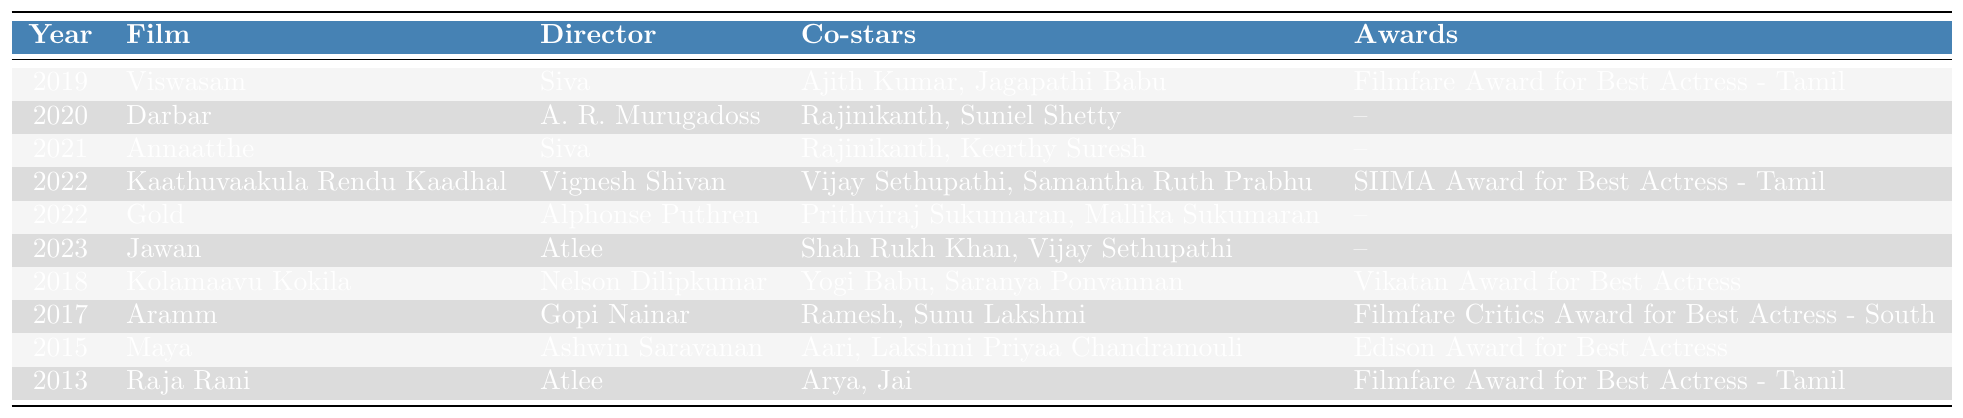What film did Nayanthara star in alongside Rajinikanth in 2020? The table shows that in the year 2020, Nayanthara starred in the film "Darbar," with Rajinikanth as a co-star.
Answer: Darbar How many awards did Nayanthara win for her film "Kaathuvaakula Rendu Kaadhal"? Referring to the row for "Kaathuvaakula Rendu Kaadhal" in 2022, the table indicates that she won one award: the SIIMA Award for Best Actress - Tamil.
Answer: One award Who directed the film "Kolamaavu Kokila"? The table lists "Kolamaavu Kokila" under the year 2018 and shows that it was directed by Nelson Dilipkumar.
Answer: Nelson Dilipkumar In which year did Nayanthara collaborate with director Siva, and what films did she feature in? Nayanthara worked with director Siva in two films, "Viswasam" in 2019 and "Annaatthe" in 2021.
Answer: 2019 and 2021 Did Nayanthara receive any awards for her performance in "Jawan"? The table shows that for the film "Jawan" in 2023, Nayanthara did not win any awards, as indicated by the empty awards section for that film.
Answer: No What is the total number of awards Nayanthara has won for her films listed in the table? By counting the awards listed: 1 (Filmfare for Viswasam) + 1 (SIIMA for Kaathuvaakula Rendu Kaadhal) + 1 (Vikatan for Kolamaavu Kokila) + 1 (Filmfare Critics for Aramm) + 1 (Edison for Maya) + 1 (Filmfare for Raja Rani) = 6 awards total.
Answer: 6 awards Which film had the most notable co-stars listed, and who were they? The film with the most notable co-stars is "Jawan" from 2023, featuring Shah Rukh Khan and Vijay Sethupathi as co-stars.
Answer: Jawan; Shah Rukh Khan, Vijay Sethupathi Which director worked with Nayanthara in the maximum number of films according to the table? After reviewing the table, Siva directed Nayanthara in two films: "Viswasam" and "Annaatthe," which is the highest among the directors listed.
Answer: Siva What film did Nayanthara star in before "Annaatthe" and what year was it released? The film that Nayanthara starred in before "Annaatthe" is "Darbar," which was released in 2020.
Answer: Darbar, 2020 Is it true that Nayanthara starred with both Ajith Kumar and Rajinikanth in the same film? The table indicates that Nayanthara starred with Ajith Kumar in "Viswasam" and with Rajinikanth in "Darbar" and "Annaatthe," but there is no film where they appeared together.
Answer: False 